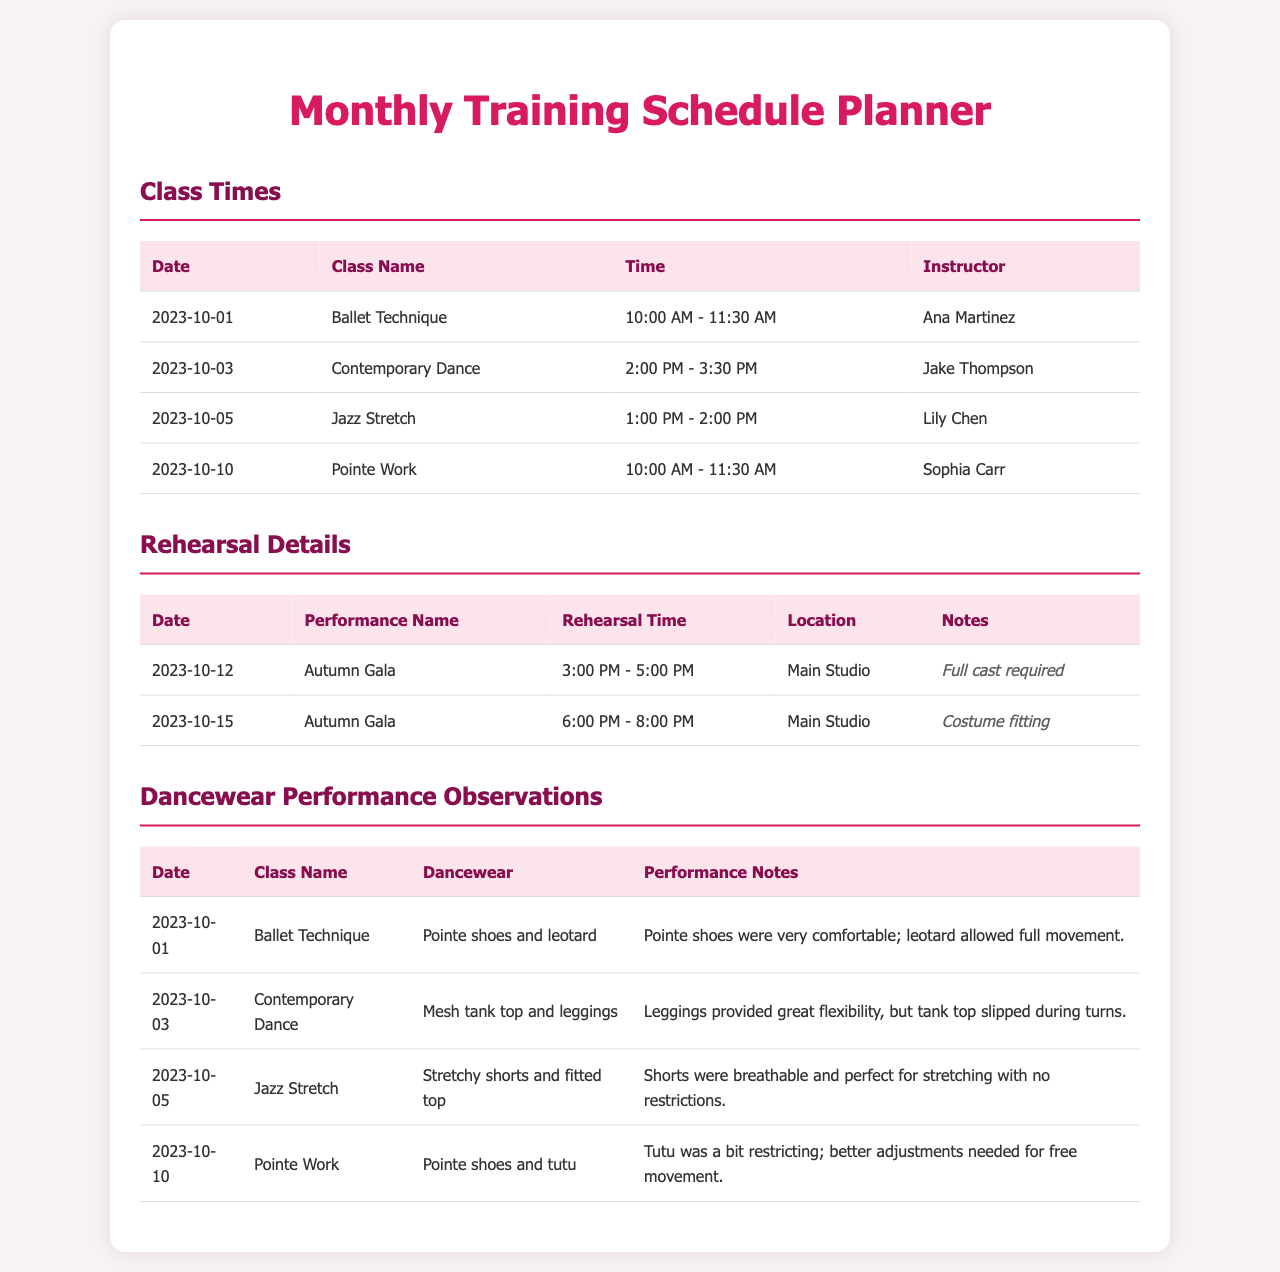what is the next class after Ballet Technique? The schedule shows Contemporary Dance on 2023-10-03 after Ballet Technique on 2023-10-01.
Answer: Contemporary Dance who is the instructor for Jazz Stretch? The table for class times indicates Lily Chen as the instructor for Jazz Stretch.
Answer: Lily Chen what time does Pointe Work start? The class times table lists Pointe Work starting at 10:00 AM on 2023-10-10.
Answer: 10:00 AM how long is the rehearsal for the Autumn Gala on 2023-10-15? The rehearsal time for the Autumn Gala is listed as 6:00 PM to 8:00 PM, which is a 2-hour duration.
Answer: 2 hours what was noted about the leotard during Ballet Technique? The observations indicate that the leotard allowed full movement during Ballet Technique.
Answer: Allowed full movement which dancewear was worn during Contemporary Dance? The dancewear section shows a mesh tank top and leggings were worn during Contemporary Dance.
Answer: Mesh tank top and leggings what is the location for the rehearsal on 2023-10-12? The rehearsal details specify the location as Main Studio for the Autumn Gala.
Answer: Main Studio what adjustments are needed for the tutu during Pointe Work? The performance notes highlight that better adjustments are needed for free movement with the tutu.
Answer: Better adjustments needed for free movement 